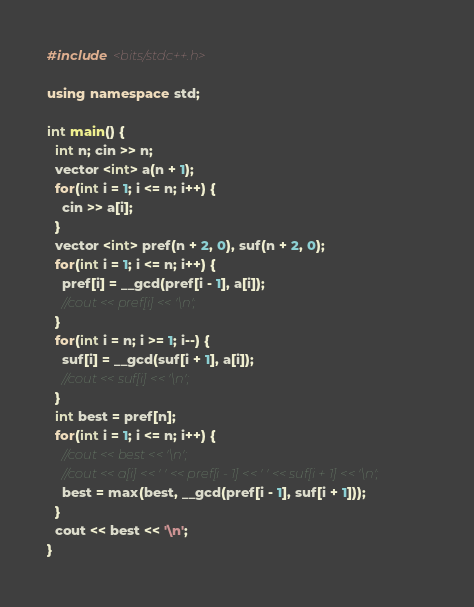Convert code to text. <code><loc_0><loc_0><loc_500><loc_500><_C++_>#include <bits/stdc++.h>

using namespace std;

int main() {
  int n; cin >> n;
  vector <int> a(n + 1);
  for(int i = 1; i <= n; i++) {
    cin >> a[i];
  }
  vector <int> pref(n + 2, 0), suf(n + 2, 0);
  for(int i = 1; i <= n; i++) {
    pref[i] = __gcd(pref[i - 1], a[i]);
    //cout << pref[i] << '\n';
  }
  for(int i = n; i >= 1; i--) {
    suf[i] = __gcd(suf[i + 1], a[i]);
    //cout << suf[i] << '\n';
  }
  int best = pref[n];
  for(int i = 1; i <= n; i++) {
    //cout << best << '\n';
    //cout << a[i] << ' ' << pref[i - 1] << ' ' << suf[i + 1] << '\n';
    best = max(best, __gcd(pref[i - 1], suf[i + 1]));
  }
  cout << best << '\n';
}
</code> 